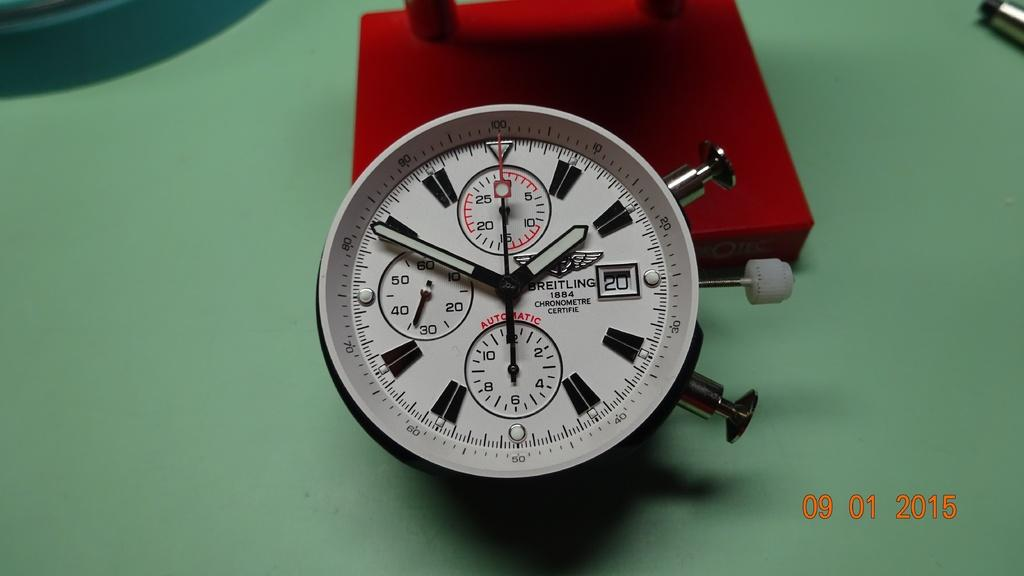Provide a one-sentence caption for the provided image. A Breitling gauge rests on a green table. 